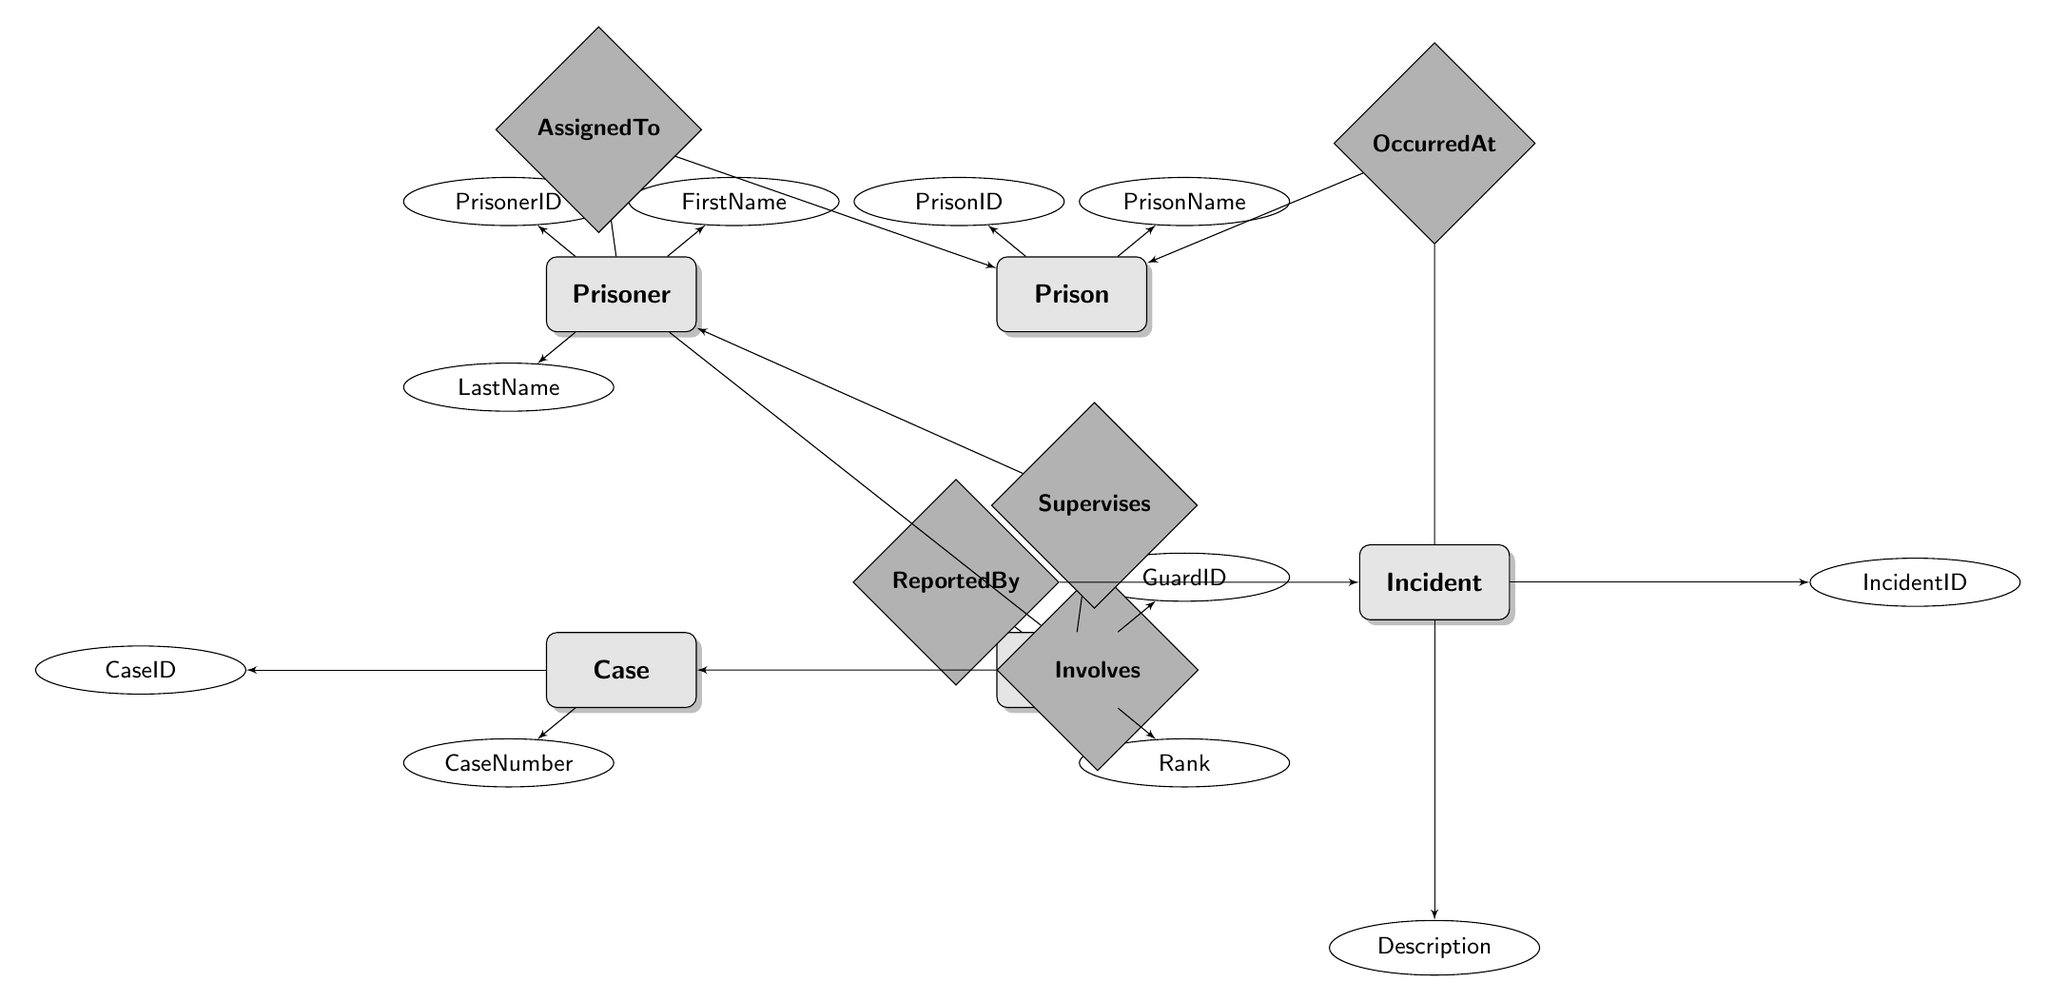What are the main entities in the diagram? The diagram includes entities such as Prisoner, Prison, Case, Guard, and Incident. Each entity represents a different aspect of the prison system.
Answer: Prisoner, Prison, Case, Guard, Incident How many attributes does the Prison entity have? The Prison entity has two attributes: PrisonID and PrisonName. This is evident from the attributes listed under the Prison entity in the diagram.
Answer: 2 What does the relationship "AssignedTo" connect? The "AssignedTo" relationship connects the entities Prisoner and Prison, indicating that a prisoner is assigned to a specific prison.
Answer: Prisoner and Prison What is the role of the Guard in relation to the Incident? The Guard is associated with the Incident through the "ReportedBy" relationship, indicating that a guard reports incidents that occur in the prison.
Answer: ReportedBy How many relationships are present in the diagram? There are five relationships illustrated in the diagram: AssignedTo, Involves, Supervises, OccurredAt, and ReportedBy. Each relationship connects different entities in the context of a prison environment.
Answer: 5 What is the purpose of the "Involves" relationship? The "Involves" relationship illustrates the connection between a Prisoner and a Case, specifying the role a prisoner has concerning a particular case.
Answer: Role Which entity has the attribute "Rank"? The Guard entity has the attribute "Rank," indicating the rank or position of the guard within the prison hierarchy.
Answer: Guard What kind of information is included in the Incident entity? The Incident entity includes identifiers such as IncidentID and also a Description of the incident, summarizing what occurred.
Answer: IncidentID, Description What is the significance of the "Supervises" relationship? The "Supervises" relationship indicates the oversight role of a Guard over a Prisoner, showing that guards monitor prisoners during their incarceration.
Answer: Supervises 